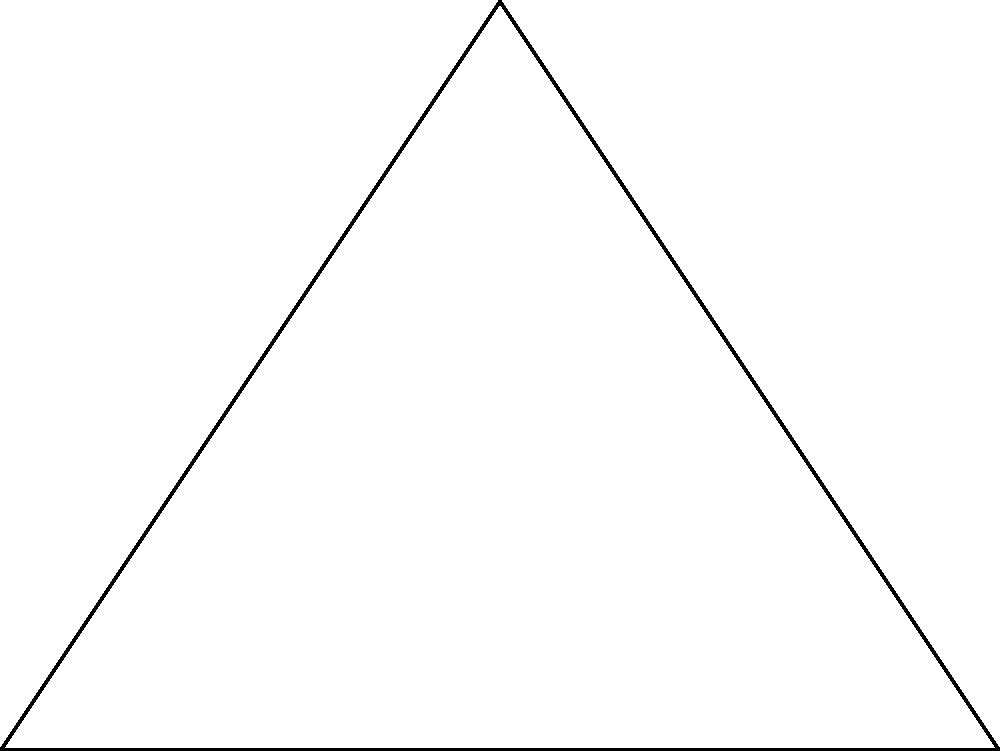As you plan the construction of a new stupa, you've been offered a triangular plot of land. The base of the triangle measures 8 meters, and the height from the base to the opposite vertex is 6 meters. What is the area of this sacred space in square meters? To find the area of the triangular plot, we can use the formula for the area of a triangle:

$$A = \frac{1}{2} \times base \times height$$

Given:
- Base (b) = 8 meters
- Height (h) = 6 meters

Let's substitute these values into the formula:

$$A = \frac{1}{2} \times 8 \times 6$$

Now, let's calculate:

$$A = \frac{1}{2} \times 48$$
$$A = 24$$

Therefore, the area of the triangular plot for the new stupa is 24 square meters.

This calculation reminds us of the Buddhist principle of precision and mindfulness in our actions, even in mathematical computations for sacred spaces.
Answer: 24 m² 